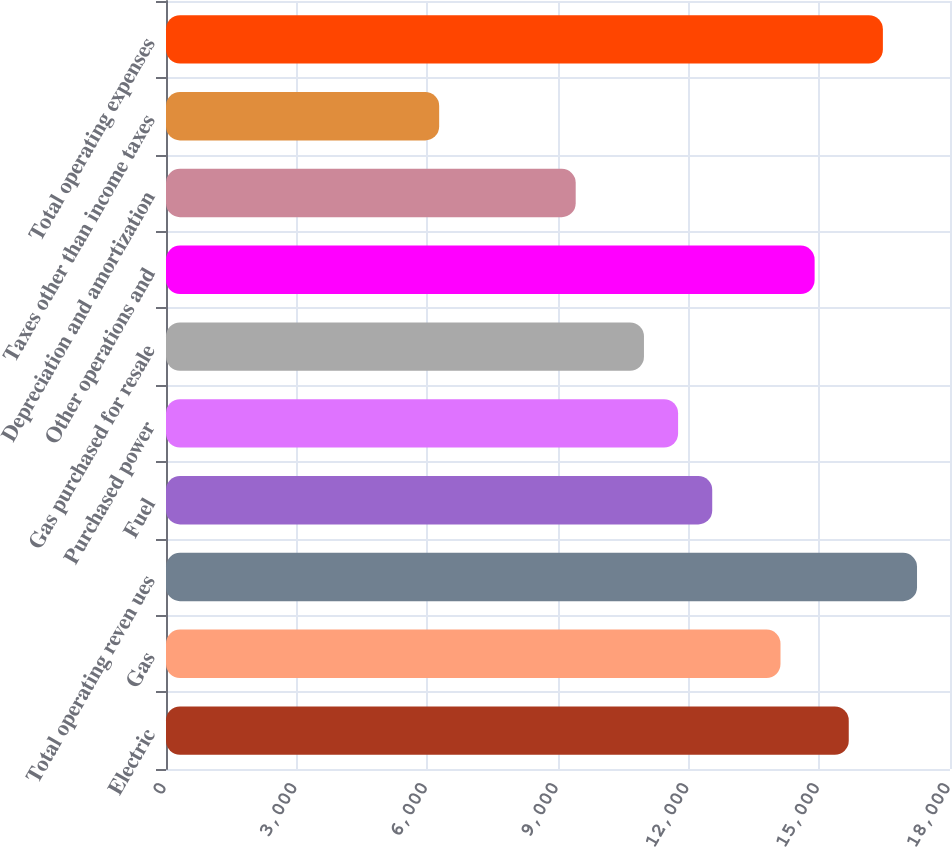<chart> <loc_0><loc_0><loc_500><loc_500><bar_chart><fcel>Electric<fcel>Gas<fcel>Total operating reven ues<fcel>Fuel<fcel>Purchased power<fcel>Gas purchased for resale<fcel>Other operations and<fcel>Depreciation and amortization<fcel>Taxes other than income taxes<fcel>Total operating expenses<nl><fcel>15675.5<fcel>14108.2<fcel>17242.8<fcel>12540.9<fcel>11757.3<fcel>10973.6<fcel>14891.9<fcel>9406.34<fcel>6271.74<fcel>16459.2<nl></chart> 